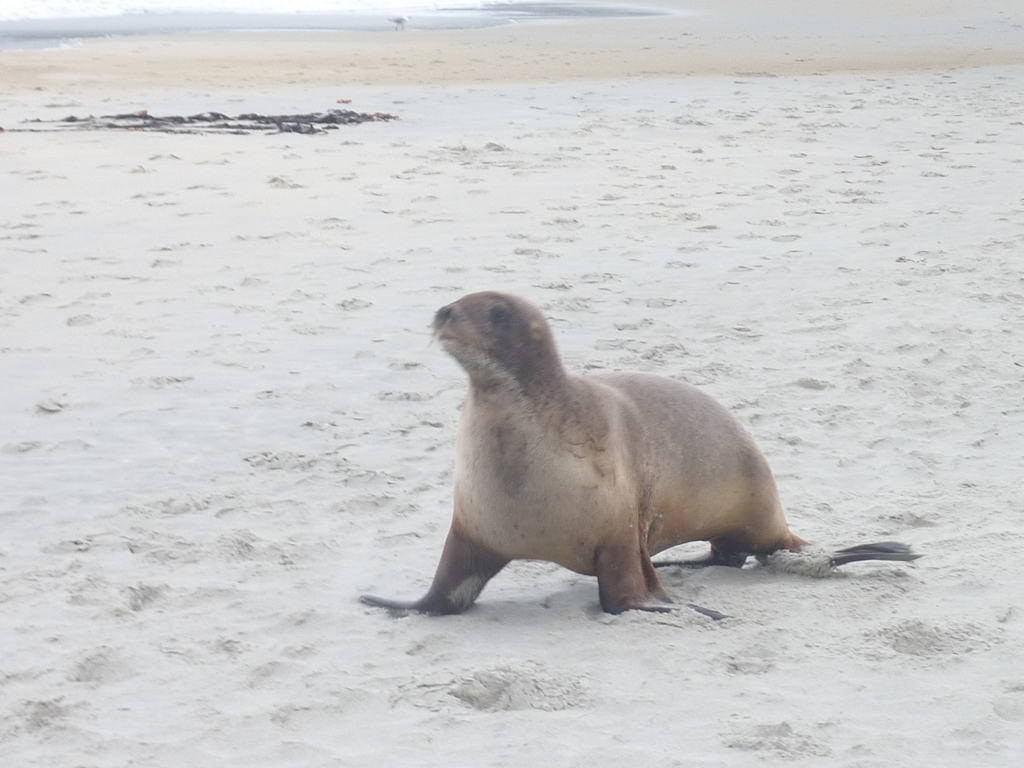Is the image content clear or blurry? The image's quality skews towards the blurry side, especially around the moving seal, which is the main subject. The background, however, including the sand and the distant water, retains some level of clarity despite the overall lack of sharpness. 